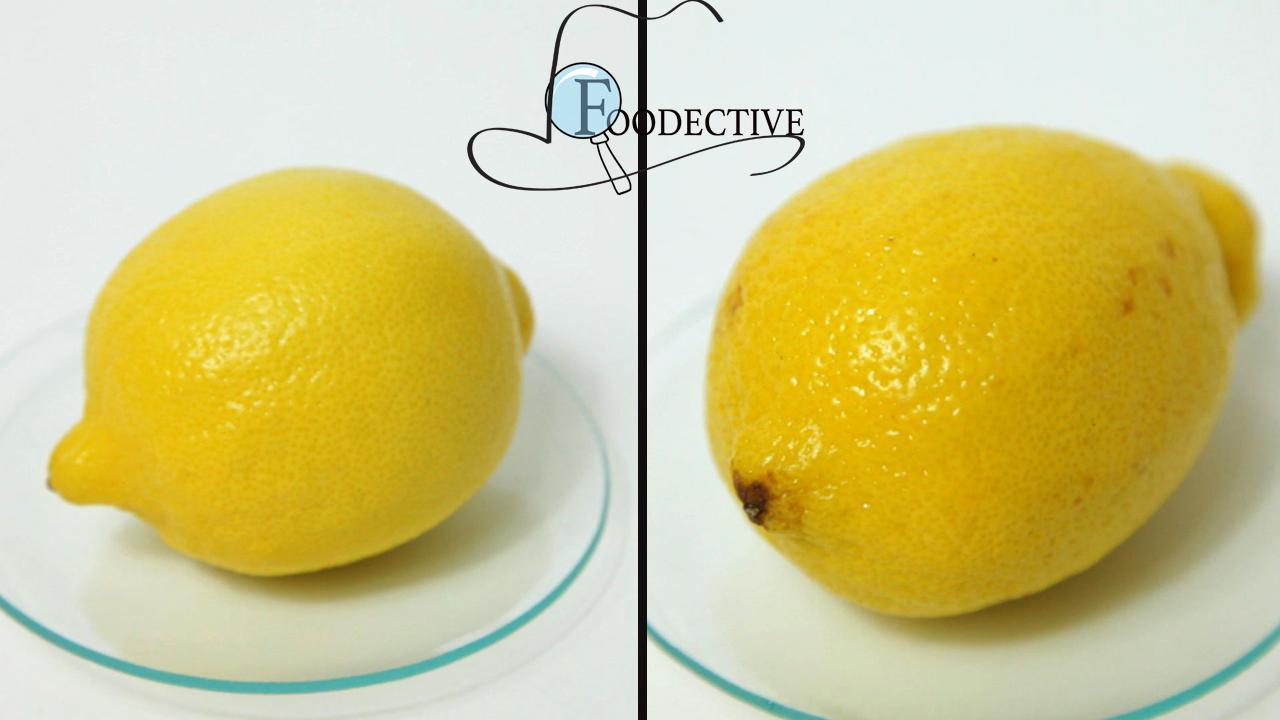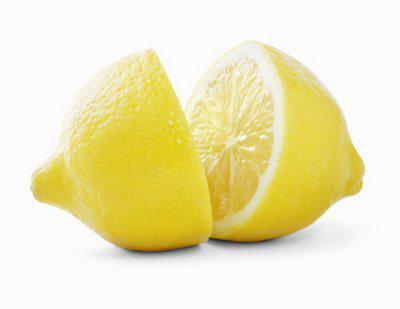The first image is the image on the left, the second image is the image on the right. Evaluate the accuracy of this statement regarding the images: "One image contains exactly two intact lemons, and the other includes a lemon half.". Is it true? Answer yes or no. Yes. The first image is the image on the left, the second image is the image on the right. Assess this claim about the two images: "The left image contains exactly two uncut lemons.". Correct or not? Answer yes or no. Yes. 